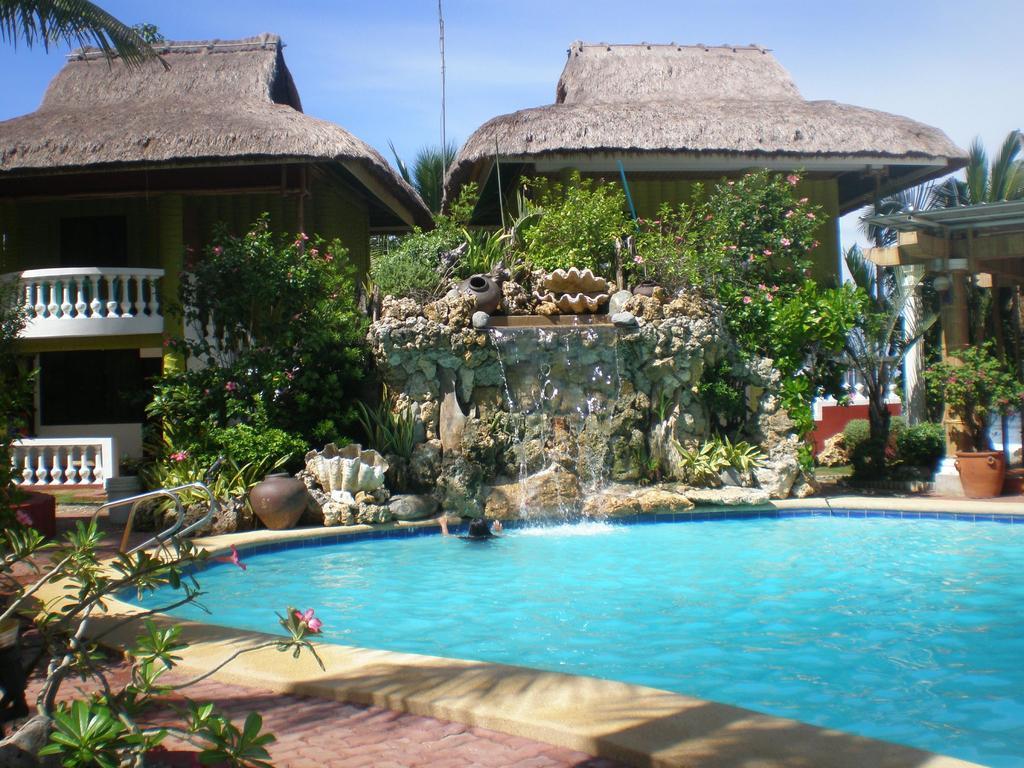Please provide a concise description of this image. In this image, we can see some water. There are a few houses. We can see the ground with some objects like a plant in a pot. We can also see the waterfall and some pots. We can see some trees and the sky. We can see some pillars and the shed. 